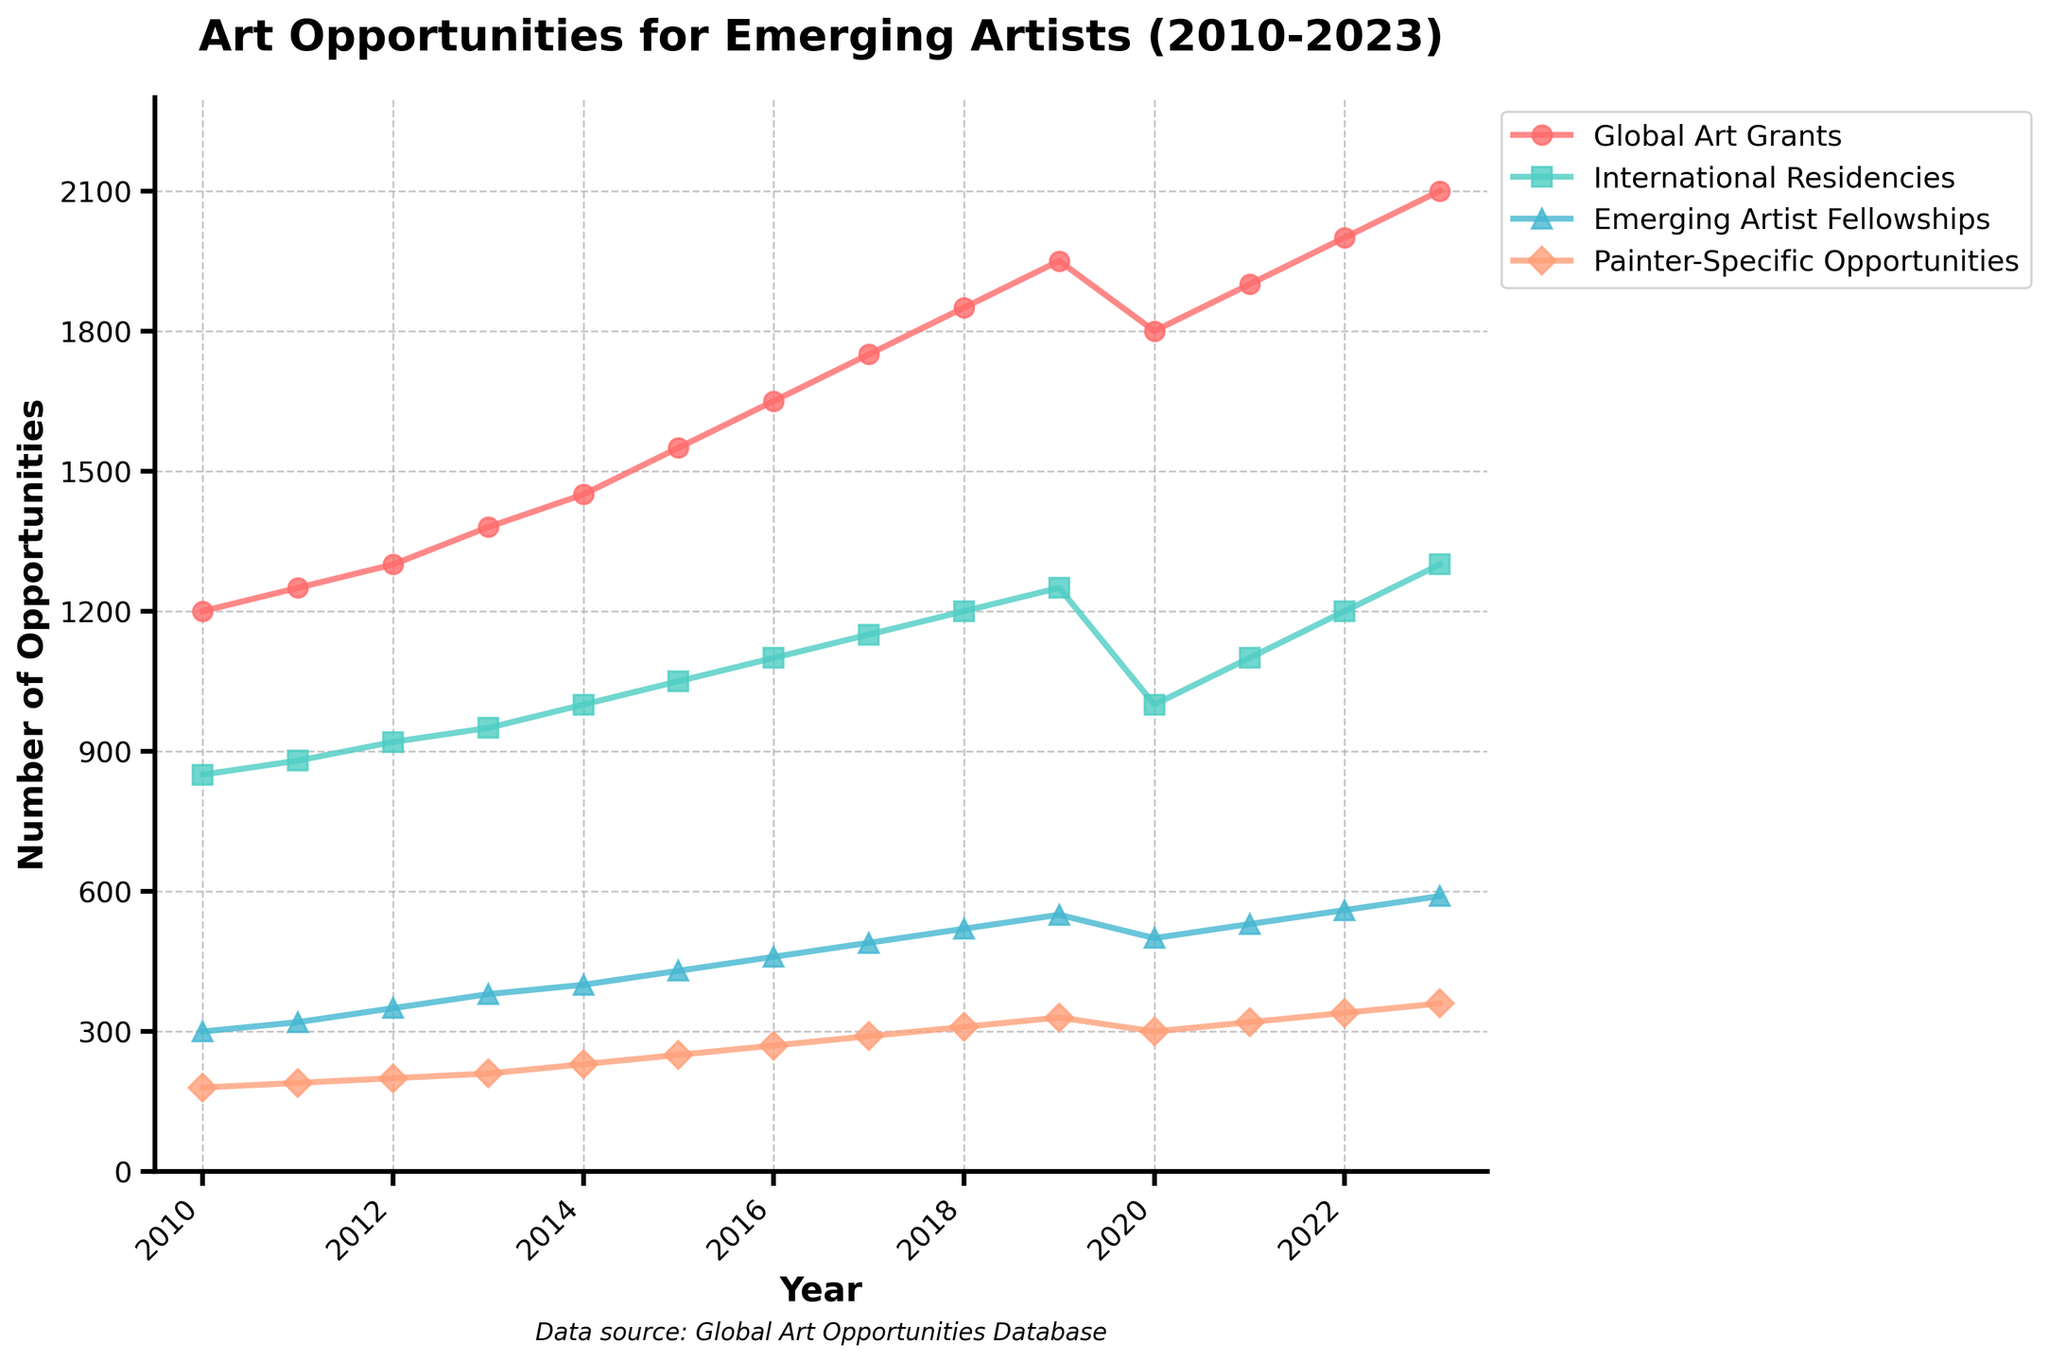What year had the highest number of Global Art Grants? From the figure, identify the year with the peak highest point on the line representing Global Art Grants.
Answer: 2023 How did the number of Painter-Specific Opportunities change from 2012 to 2014? The Painter-Specific Opportunities in 2012 was 200 and increased to 230 in 2014. The change is calculated as 230 - 200 = 30.
Answer: Increased by 30 Which category had a decrease in 2020 compared to the previous year? Look at all the lines on the chart and identify which line dips from 2019 to 2020.
Answer: Global Art Grants, International Residencies What is the overall trend in Total Opportunities from 2010 to 2023? Observe the line representing Total Opportunities and note the general direction from the start to the end.
Answer: Increasing By how much did International Residencies increase from 2016 to 2018? The number of International Residencies in 2016 was 1100 and in 2018 was 1200. Calculate the difference: 1200 - 1100 = 100.
Answer: 100 In which year did Emerging Artist Fellowships equal 490 for the first time? Find the first occurrence of the value 490 on the Emerging Artist Fellowships line.
Answer: 2017 What was the number of Total Opportunities available in 2019? Refer to the specific point for 2019 on the Total Opportunities line.
Answer: 4080 Compare Global Art Grants and Painter-Specific Opportunities in 2013. Which was higher, and by how much? Global Art Grants in 2013 was 1380 and Painter-Specific Opportunities was 210. Calculate the difference: 1380 - 210 = 1170.
Answer: Global Art Grants by 1170 From 2020 to 2021, how did the number of International Residencies change? Identify the values for International Residencies in 2020 (1000) and 2021 (1100), then calculate the change: 1100 - 1000 = 100.
Answer: Increased by 100 Which category showed the most consistent increase over the period? Evaluate the progressions of each category line and identify which had the most stable and consistent upward trajectory.
Answer: International Residencies 